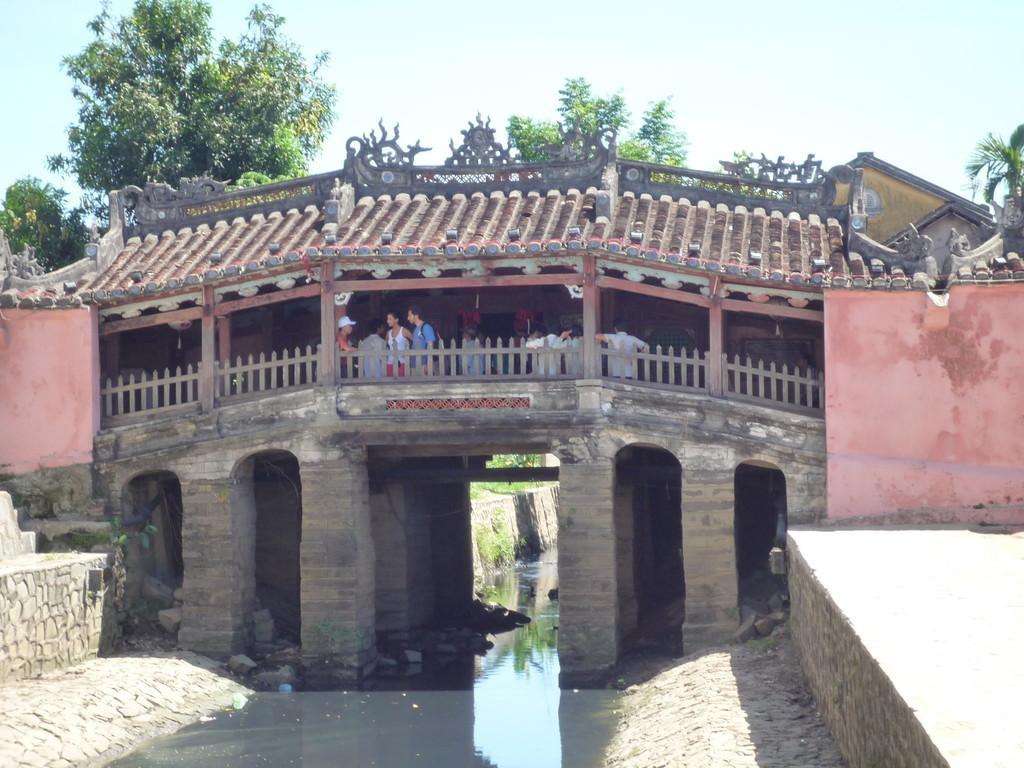What are the people in the image doing? The people in the image are on a bridge. What can be seen near the bridge? There is a fence in the image. What type of artwork is present in the image? There are sculptures in the image. What can be seen in the distance in the image? There are trees in the background of the image. What is visible at the bottom of the image? There is water visible at the bottom of the image. Can you tell me how many roses are on the bridge in the image? There are no roses present on the bridge in the image. Is there a beggar asking for money on the bridge in the image? There is no beggar present on the bridge in the image. 